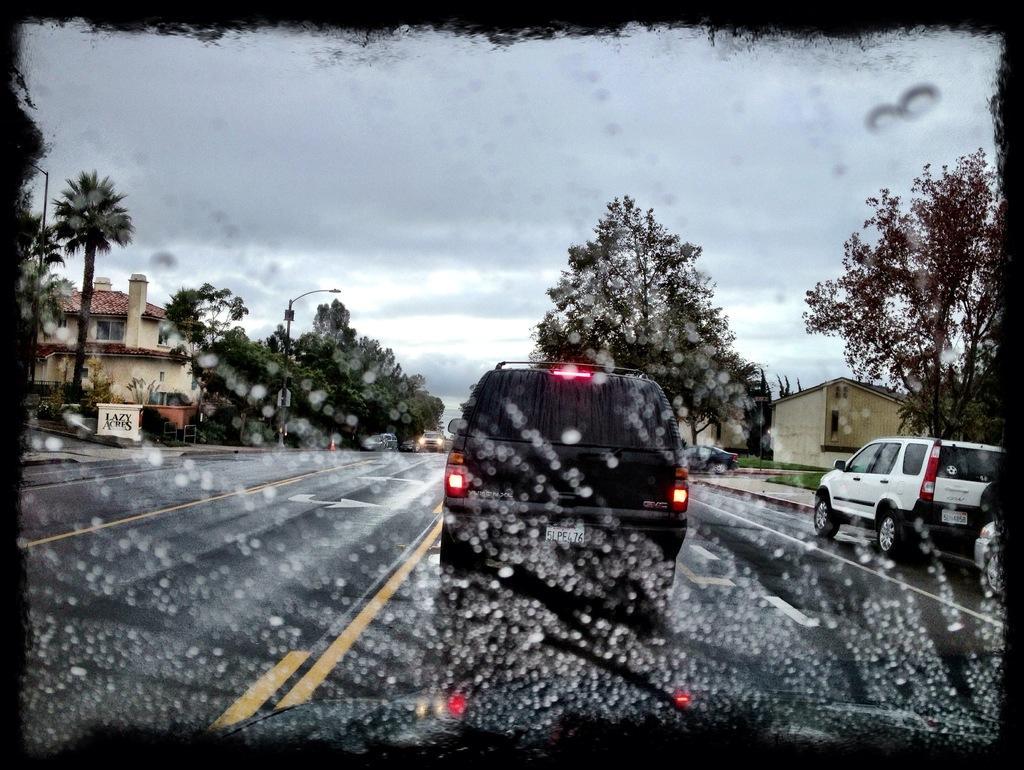In one or two sentences, can you explain what this image depicts? In this image we can see one glass with water drops. Through the glass we can see some houses, some vehicles on the road, one safety pole, one board with text, some objects on the ground, some trees, bushes, plants and grass on the ground. At the top there is the cloudy sky and it looks like raining. 